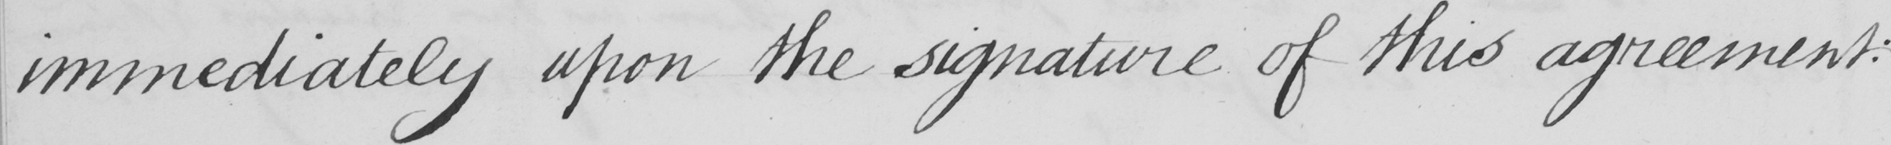What is written in this line of handwriting? immediately upon the signature of this agreement : 